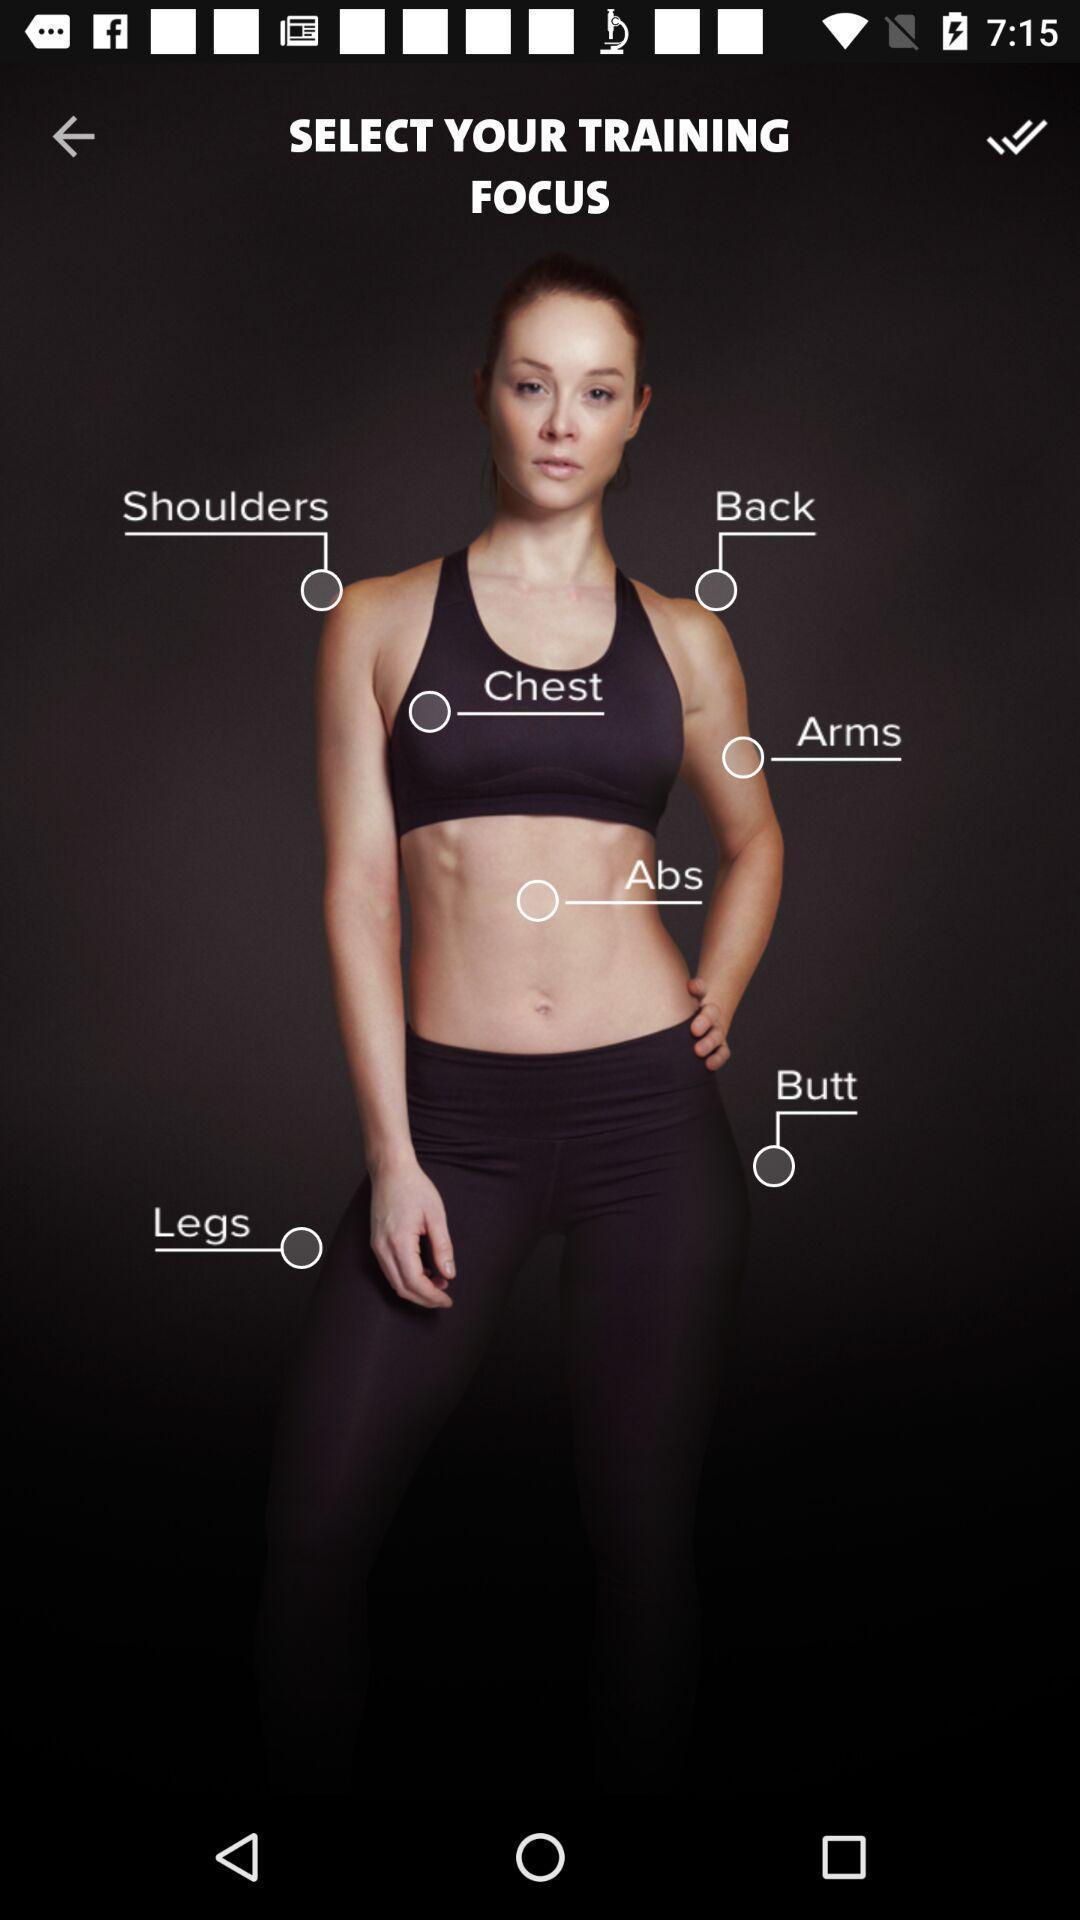Please provide a description for this image. Page showing different body targets from workout app. 